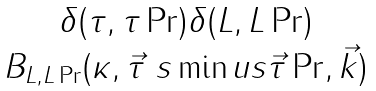Convert formula to latex. <formula><loc_0><loc_0><loc_500><loc_500>\begin{matrix} \delta ( \tau , \tau \Pr ) \delta ( L , L \Pr ) \\ B _ { L , L \Pr } ( \kappa , \vec { \tau } \ s \min u s \vec { \tau } \Pr , \vec { k } ) \\ \end{matrix}</formula> 